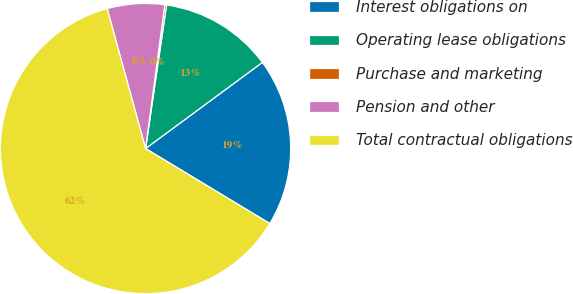<chart> <loc_0><loc_0><loc_500><loc_500><pie_chart><fcel>Interest obligations on<fcel>Operating lease obligations<fcel>Purchase and marketing<fcel>Pension and other<fcel>Total contractual obligations<nl><fcel>18.76%<fcel>12.57%<fcel>0.2%<fcel>6.38%<fcel>62.09%<nl></chart> 